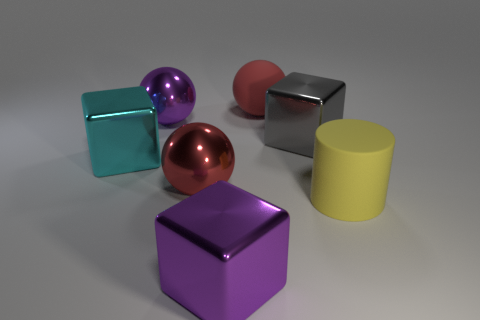Is the red metallic thing the same shape as the large gray metal object?
Your answer should be very brief. No. Are there any other things that have the same size as the yellow cylinder?
Ensure brevity in your answer.  Yes. The other red thing that is the same shape as the red matte object is what size?
Keep it short and to the point. Large. Is the number of big yellow cylinders behind the gray cube greater than the number of big shiny blocks in front of the big cyan shiny cube?
Keep it short and to the point. No. Do the cyan block and the big thing on the right side of the gray block have the same material?
Offer a terse response. No. Are there any other things that are the same shape as the large red metallic object?
Your response must be concise. Yes. What color is the big object that is both to the right of the big red rubber sphere and in front of the gray cube?
Your response must be concise. Yellow. There is a rubber thing to the left of the large gray metal object; what is its shape?
Your answer should be compact. Sphere. There is a rubber thing that is in front of the matte thing behind the metal object that is behind the big gray object; what size is it?
Keep it short and to the point. Large. What number of big gray metal objects are to the left of the rubber thing left of the big yellow matte thing?
Provide a short and direct response. 0. 